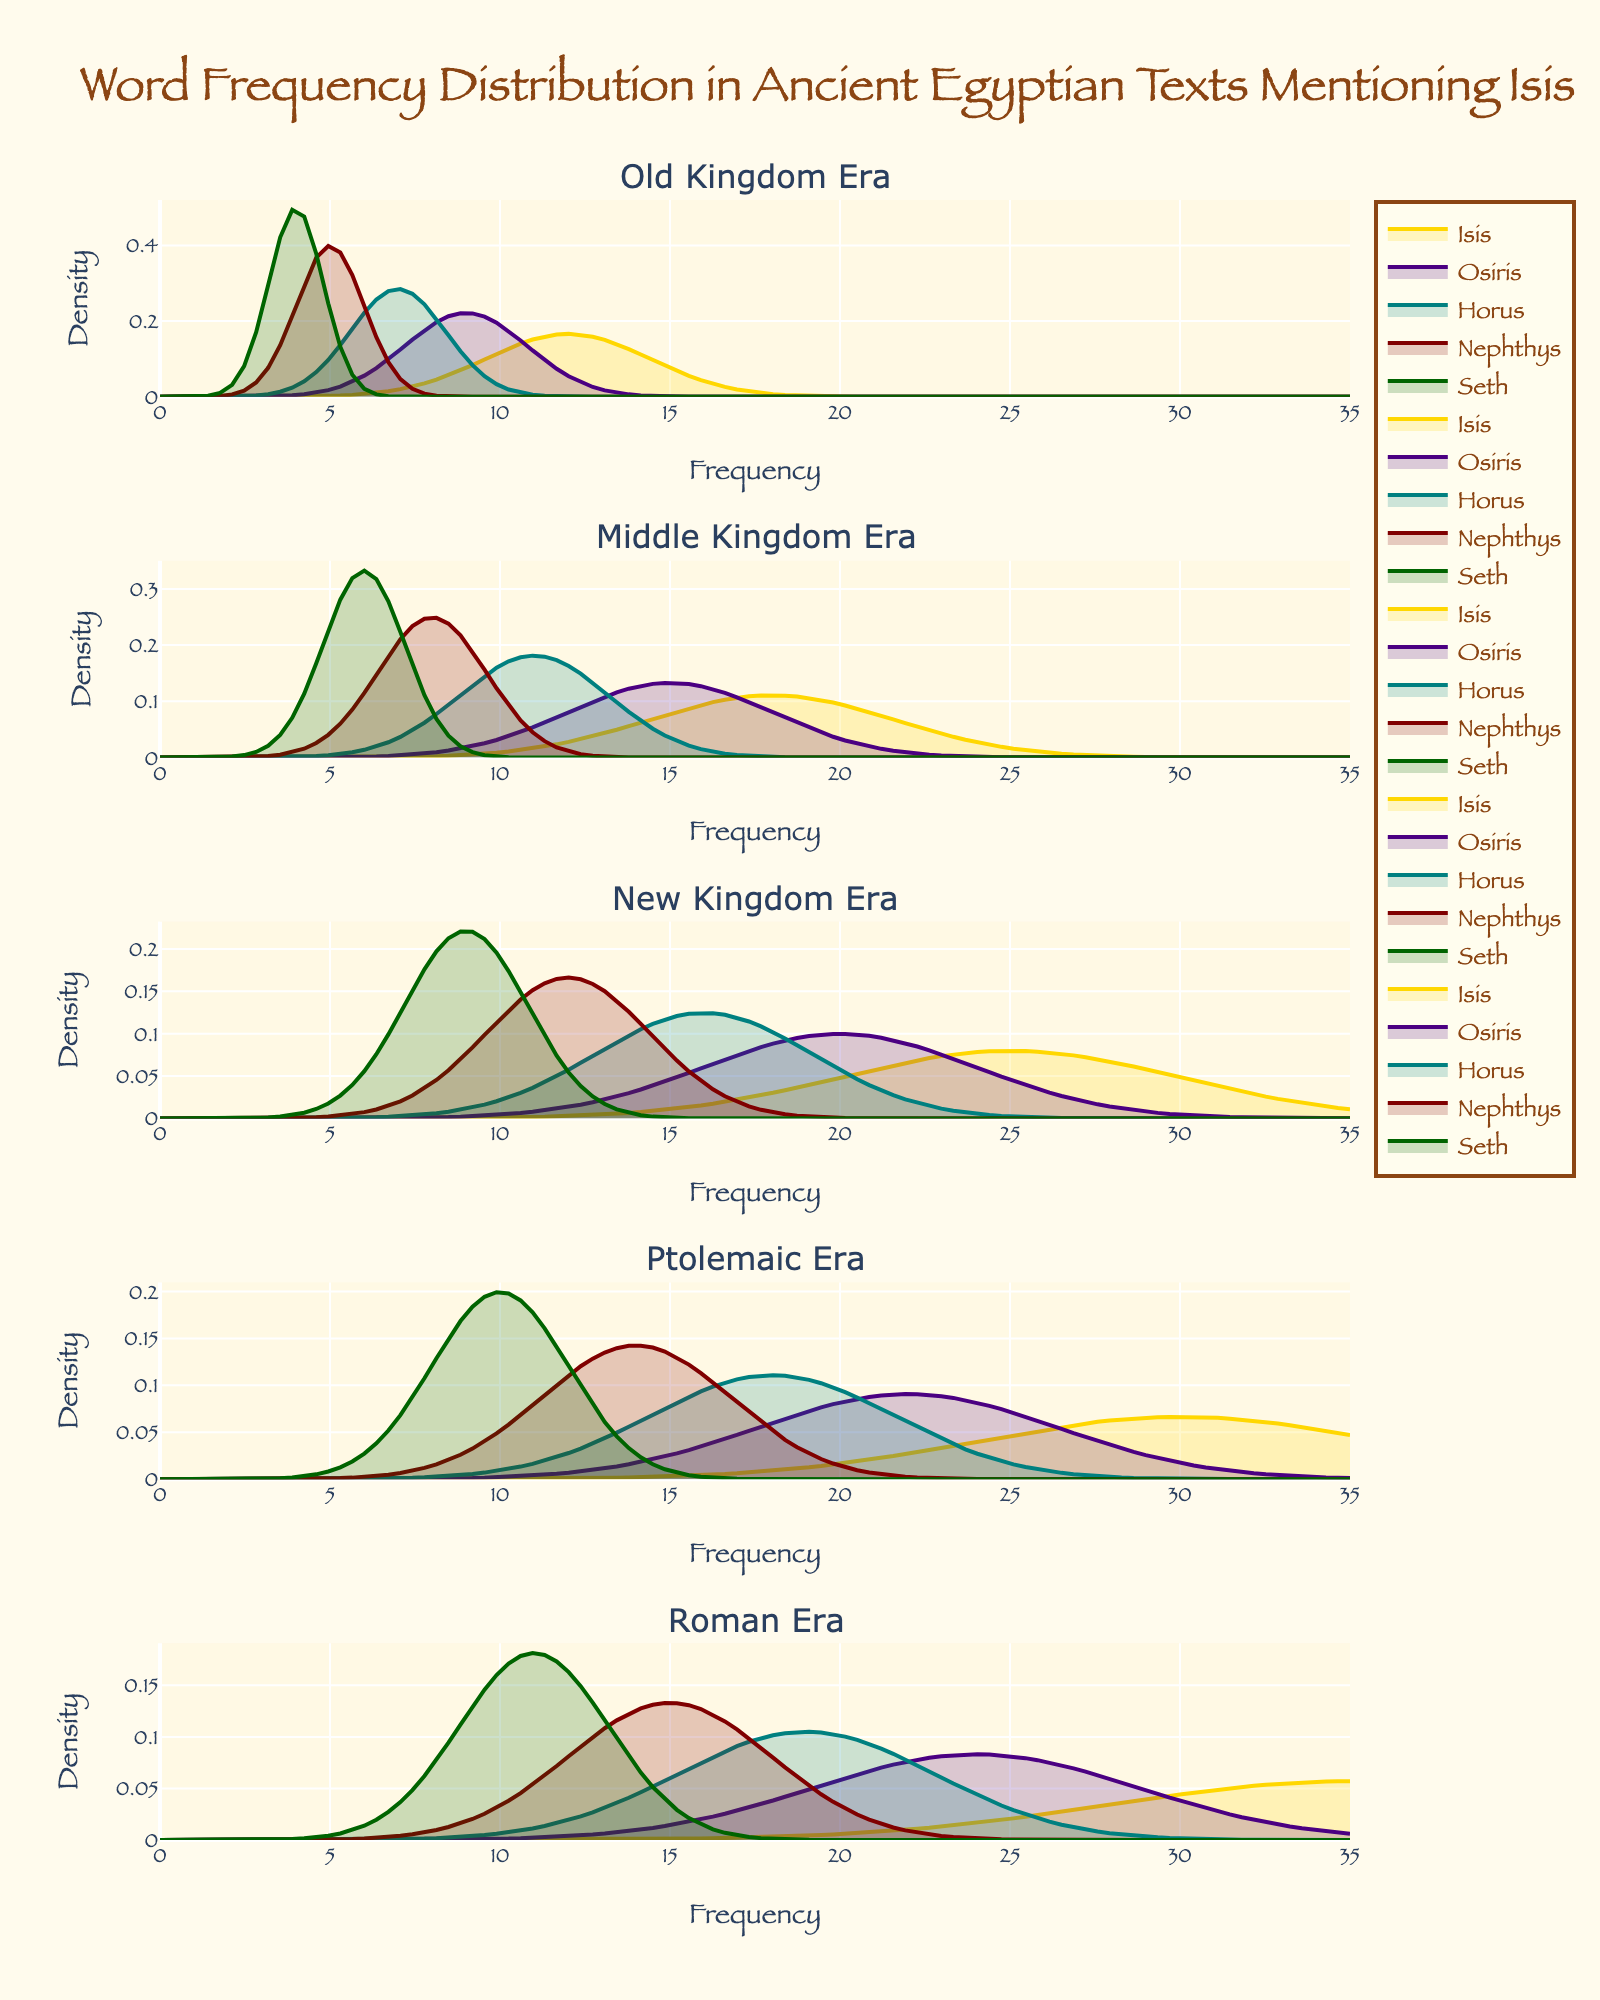what is the title of the plot? The title of the plot is displayed at the top of the figure. It states "Word Frequency Distribution in Ancient Egyptian Texts Mentioning Isis".
Answer: Word Frequency Distribution in Ancient Egyptian Texts Mentioning Isis which era has the highest frequency for 'Isis'? To determine which era has the highest frequency for 'Isis', examine the peak of the density plots for each era. The highest peak for 'Isis' appears in the Roman Era.
Answer: Roman how many subplots does the figure contain? You can count the number of titles indicating different eras in the figure. There are five subplots, each for a different era.
Answer: Five which word, apart from 'Isis', has the highest frequency in the New Kingdom era? Look at the density plots for each word in the New Kingdom subplot. 'Osiris' has the second-highest peak after 'Isis'.
Answer: Osiris what is the median frequency of 'Isis' across all eras? The median is the middle value in an ordered list. The frequencies for 'Isis' are 12, 18, 25, 30, 35. The median value in this ordered list is the third value, which is 25.
Answer: 25 how does the frequency of 'Seth' in the Ptolemaic era compare to the Old Kingdom era? Compare the peak positions of the 'Seth' density plots from the Ptolemaic and Old Kingdom subplots. 'Seth' has a higher peak in the Ptolemaic era than in the Old Kingdom era.
Answer: higher in which era is the frequency distribution for 'Horus' the narrowest? The narrowness of the distribution is indicated by the spread of the density plot. The subplot for the Old Kingdom era shows the narrowest distribution for 'Horus'.
Answer: Old Kingdom does the frequency distribution for 'Nephthys' show an increasing trend over the eras? By observing the heights of the density plots for 'Nephthys' across different eras, one can see an increasing trend from Old Kingdom to Roman era.
Answer: Yes in which era is the word 'Osiris' almost as frequent as 'Isis'? To identify where 'Osiris' is nearly as frequent as 'Isis', compare their density plot peaks. In the Middle Kingdom era, 'Osiris' is close to 'Isis' in frequency.
Answer: Middle Kingdom 